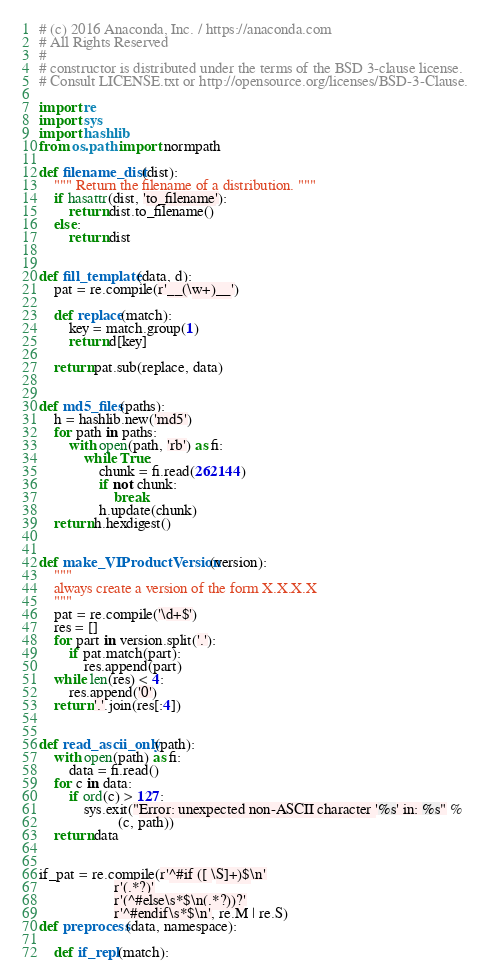<code> <loc_0><loc_0><loc_500><loc_500><_Python_># (c) 2016 Anaconda, Inc. / https://anaconda.com
# All Rights Reserved
#
# constructor is distributed under the terms of the BSD 3-clause license.
# Consult LICENSE.txt or http://opensource.org/licenses/BSD-3-Clause.

import re
import sys
import hashlib
from os.path import normpath

def filename_dist(dist):
    """ Return the filename of a distribution. """
    if hasattr(dist, 'to_filename'):
        return dist.to_filename()
    else:
        return dist


def fill_template(data, d):
    pat = re.compile(r'__(\w+)__')

    def replace(match):
        key = match.group(1)
        return d[key]

    return pat.sub(replace, data)


def md5_files(paths):
    h = hashlib.new('md5')
    for path in paths:
        with open(path, 'rb') as fi:
            while True:
                chunk = fi.read(262144)
                if not chunk:
                    break
                h.update(chunk)
    return h.hexdigest()


def make_VIProductVersion(version):
    """
    always create a version of the form X.X.X.X
    """
    pat = re.compile('\d+$')
    res = []
    for part in version.split('.'):
        if pat.match(part):
            res.append(part)
    while len(res) < 4:
        res.append('0')
    return '.'.join(res[:4])


def read_ascii_only(path):
    with open(path) as fi:
        data = fi.read()
    for c in data:
        if ord(c) > 127:
            sys.exit("Error: unexpected non-ASCII character '%s' in: %s" %
                     (c, path))
    return data


if_pat = re.compile(r'^#if ([ \S]+)$\n'
                    r'(.*?)'
                    r'(^#else\s*$\n(.*?))?'
                    r'^#endif\s*$\n', re.M | re.S)
def preprocess(data, namespace):

    def if_repl(match):</code> 